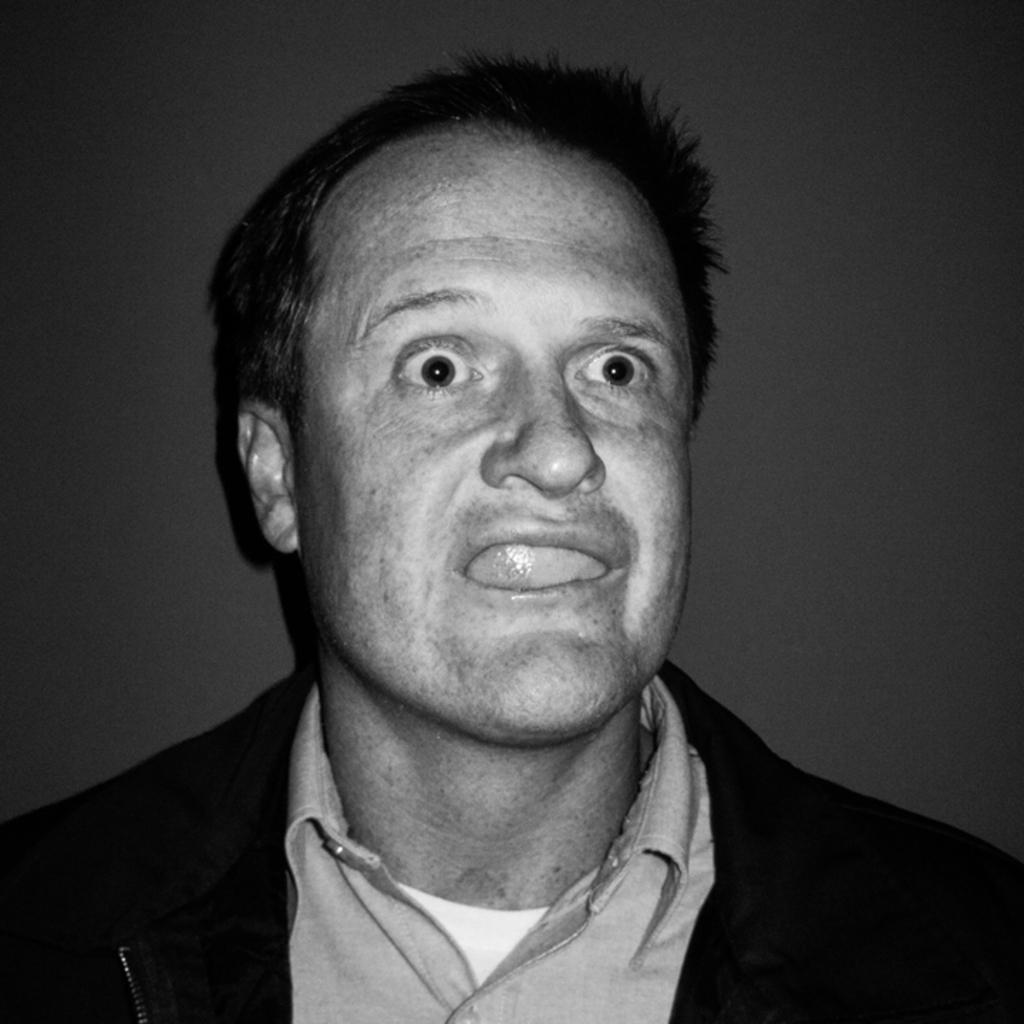What is the color scheme of the picture? The picture is black and white. Can you describe the main subject in the image? There is a man in the picture. What is the man's facial expression like? The man has a weird expression on his face. What type of wire is the man holding in the picture? There is no wire present in the image; it only features a man with a weird expression on his face. 